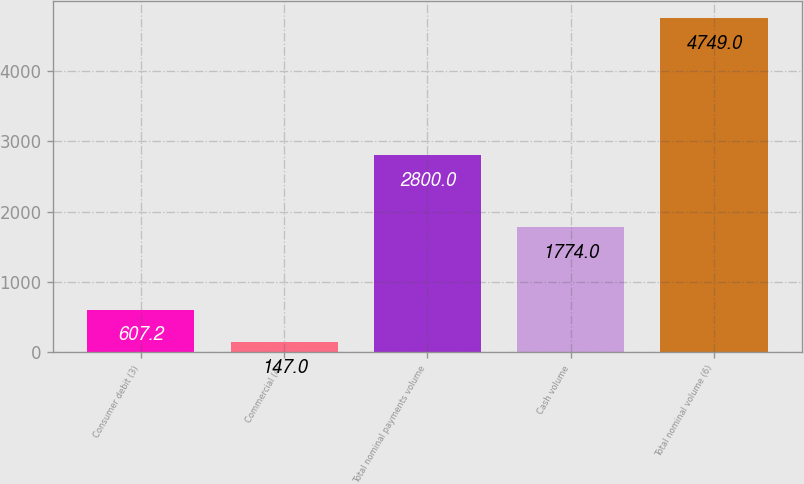Convert chart to OTSL. <chart><loc_0><loc_0><loc_500><loc_500><bar_chart><fcel>Consumer debit (3)<fcel>Commercial (4)<fcel>Total nominal payments volume<fcel>Cash volume<fcel>Total nominal volume (6)<nl><fcel>607.2<fcel>147<fcel>2800<fcel>1774<fcel>4749<nl></chart> 